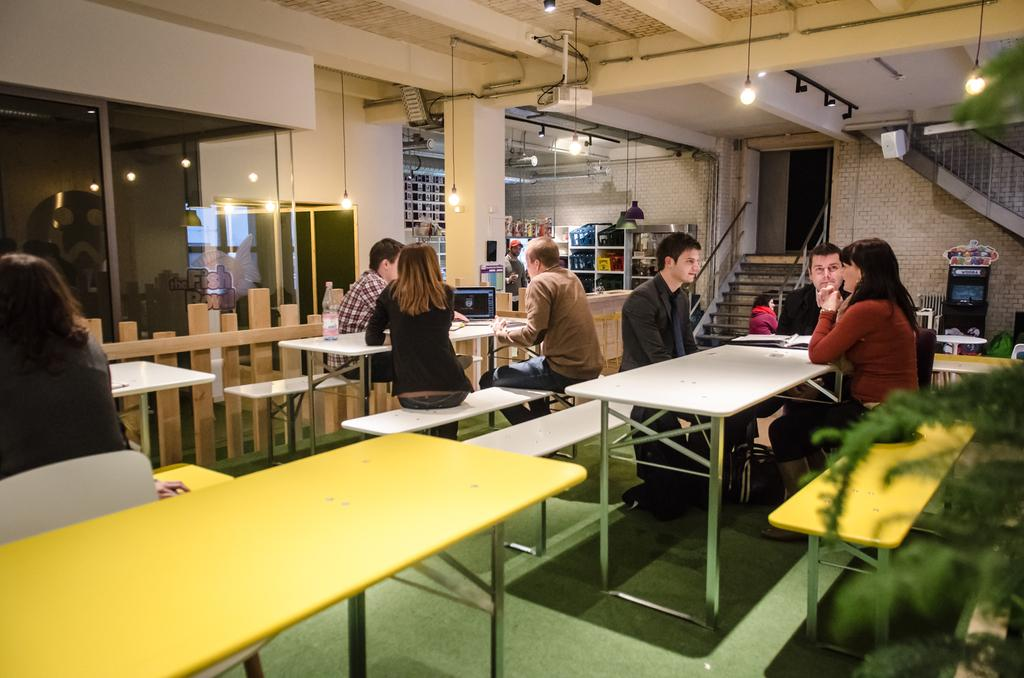What are the persons in the image doing? The persons in the image are sitting on tables in a room. What can be seen in the background of the image? There are lights and shelves in the background of the image. What architectural feature is present in the middle of the image? There is a staircase in the middle of the image. Can you tell me how many giraffes are visible in the image? There are no giraffes present in the image. What type of amusement can be seen in the image? There is no amusement depicted in the image; it shows persons sitting on tables in a room. 